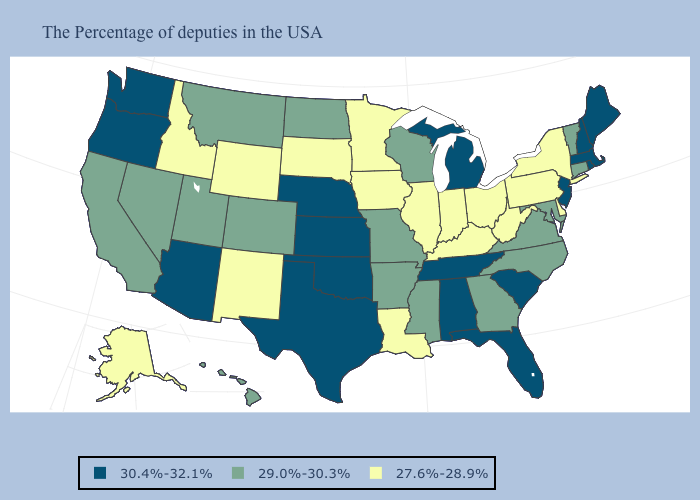Name the states that have a value in the range 27.6%-28.9%?
Write a very short answer. New York, Delaware, Pennsylvania, West Virginia, Ohio, Kentucky, Indiana, Illinois, Louisiana, Minnesota, Iowa, South Dakota, Wyoming, New Mexico, Idaho, Alaska. Does Missouri have the highest value in the MidWest?
Short answer required. No. Name the states that have a value in the range 29.0%-30.3%?
Be succinct. Vermont, Connecticut, Maryland, Virginia, North Carolina, Georgia, Wisconsin, Mississippi, Missouri, Arkansas, North Dakota, Colorado, Utah, Montana, Nevada, California, Hawaii. What is the value of South Carolina?
Answer briefly. 30.4%-32.1%. What is the value of Nebraska?
Give a very brief answer. 30.4%-32.1%. Is the legend a continuous bar?
Give a very brief answer. No. What is the highest value in the USA?
Short answer required. 30.4%-32.1%. What is the value of Kentucky?
Write a very short answer. 27.6%-28.9%. Does Rhode Island have the lowest value in the Northeast?
Quick response, please. No. What is the value of Nebraska?
Write a very short answer. 30.4%-32.1%. Is the legend a continuous bar?
Short answer required. No. Does Hawaii have the highest value in the USA?
Answer briefly. No. What is the highest value in the West ?
Short answer required. 30.4%-32.1%. How many symbols are there in the legend?
Give a very brief answer. 3. Does the first symbol in the legend represent the smallest category?
Short answer required. No. 